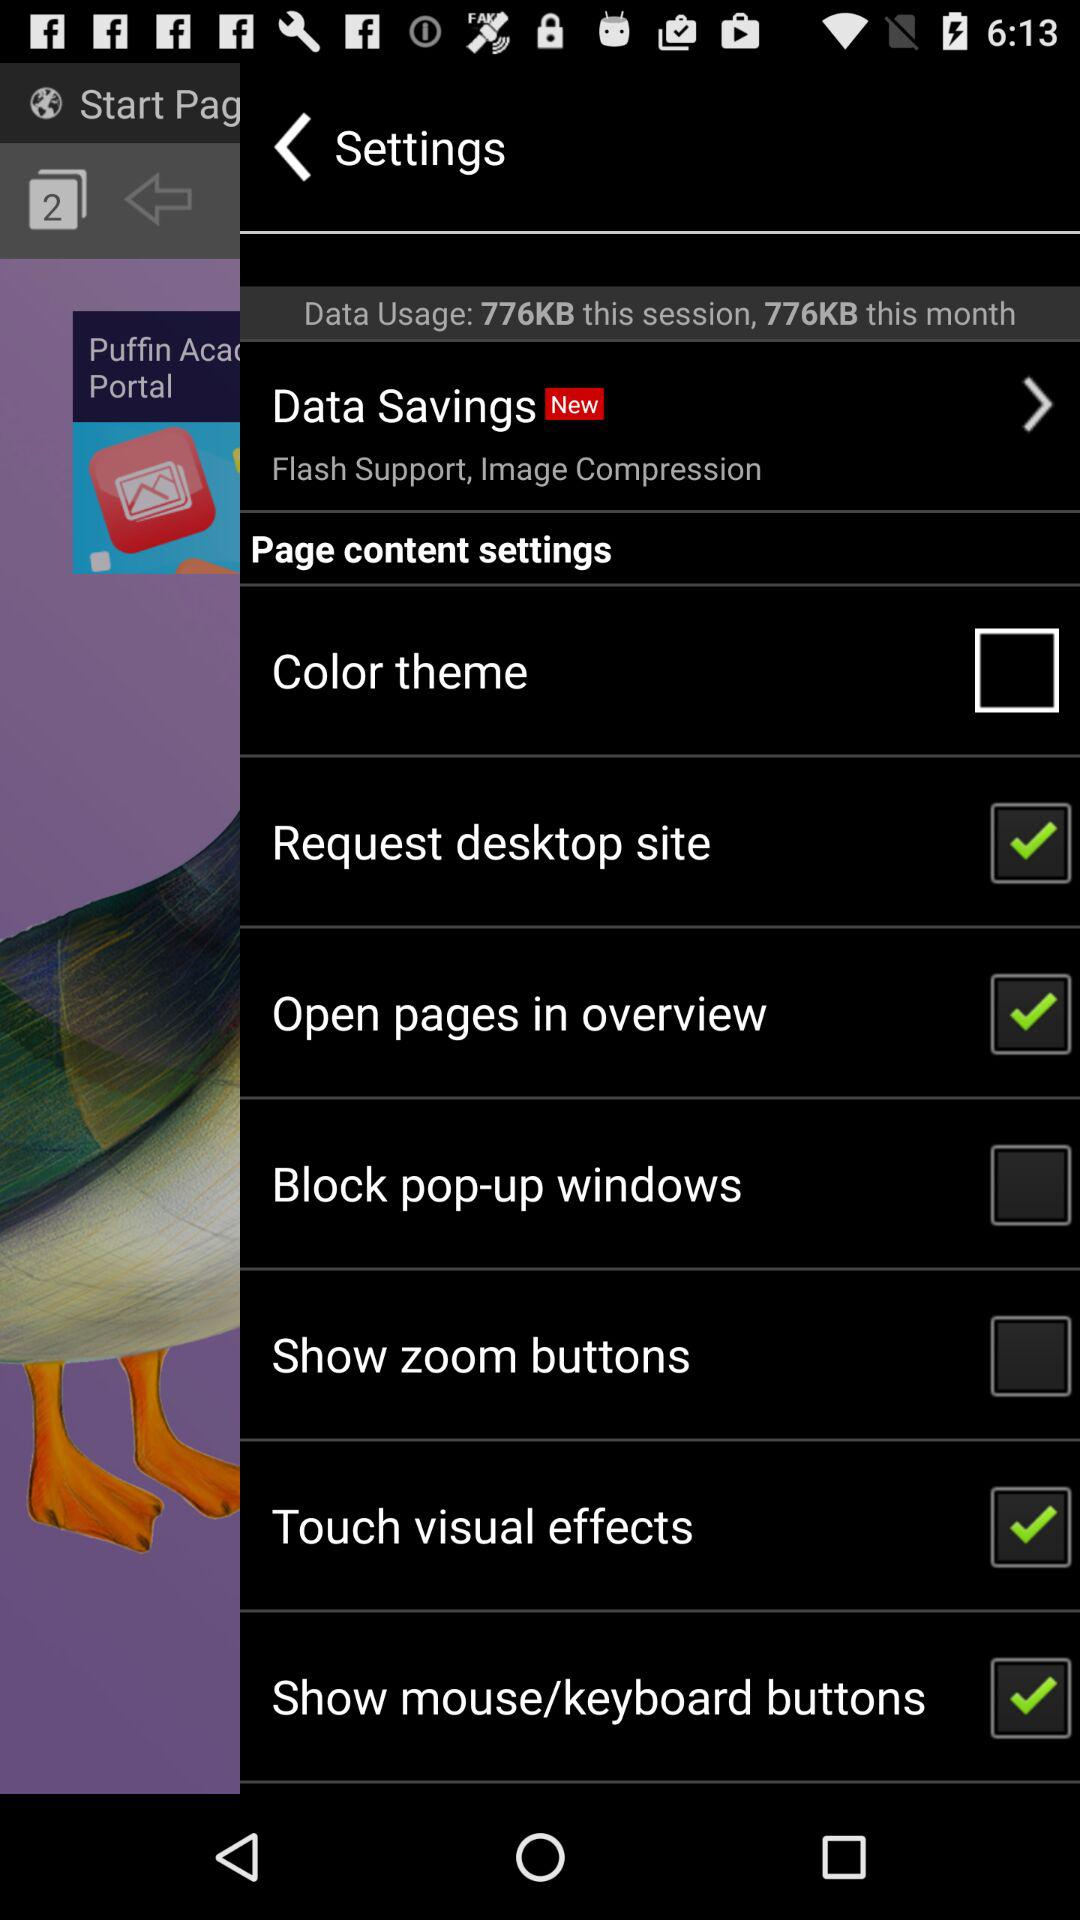Which of the settings are marked unchecked? The settings that are marked unchecked are "Color theme", "Block pop-up windows" and "Show zoom buttons". 